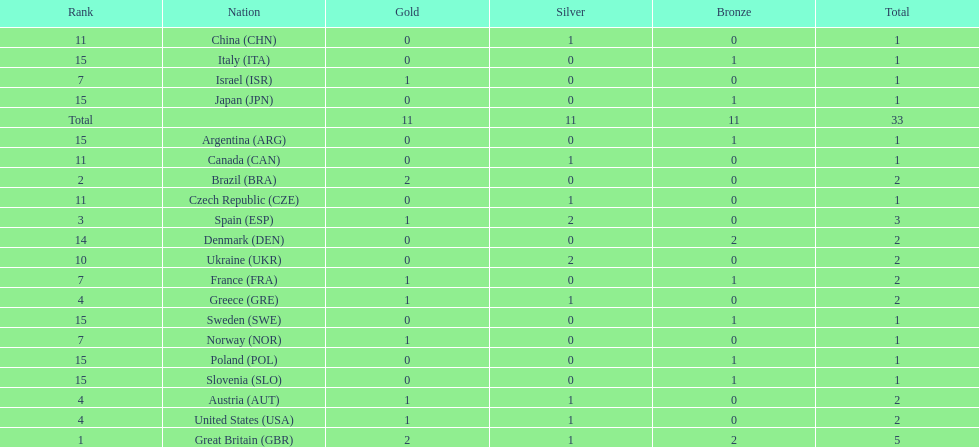What country had the most medals? Great Britain. 